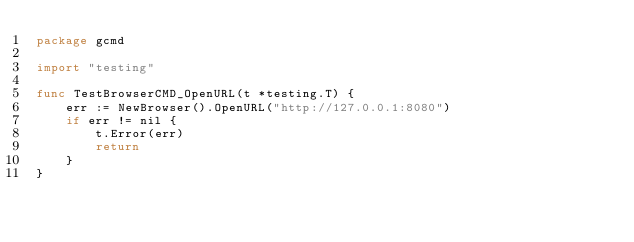<code> <loc_0><loc_0><loc_500><loc_500><_Go_>package gcmd

import "testing"

func TestBrowserCMD_OpenURL(t *testing.T) {
	err := NewBrowser().OpenURL("http://127.0.0.1:8080")
	if err != nil {
		t.Error(err)
		return
	}
}
</code> 